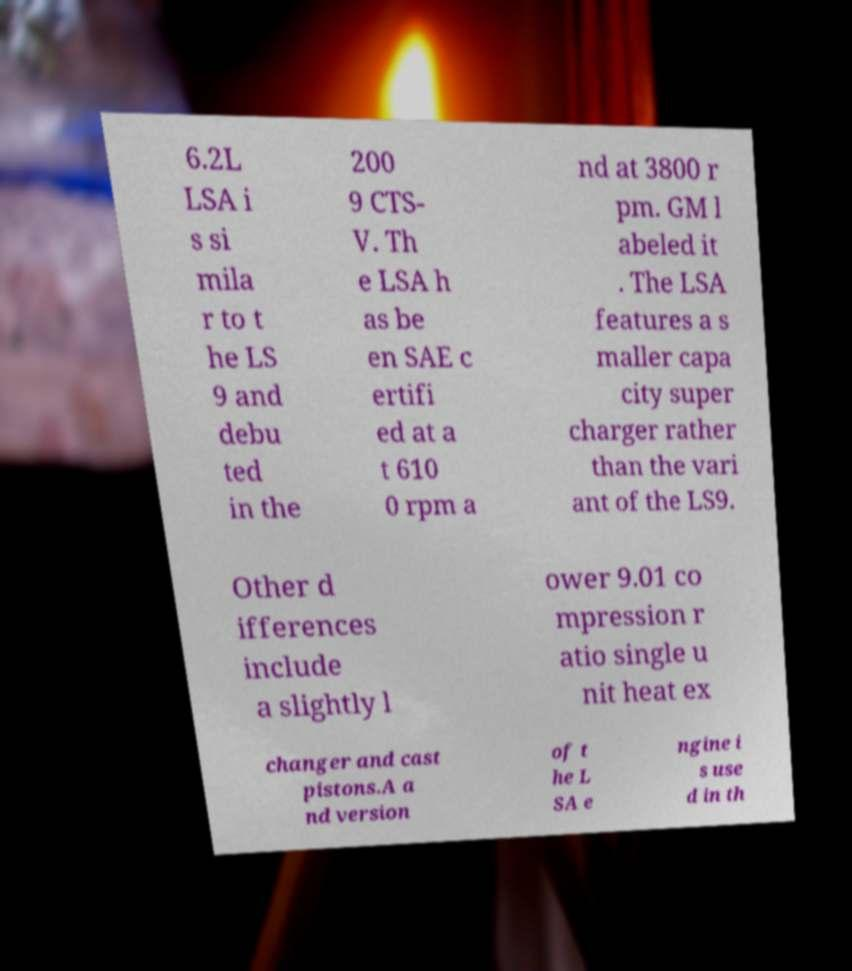Can you read and provide the text displayed in the image?This photo seems to have some interesting text. Can you extract and type it out for me? 6.2L LSA i s si mila r to t he LS 9 and debu ted in the 200 9 CTS- V. Th e LSA h as be en SAE c ertifi ed at a t 610 0 rpm a nd at 3800 r pm. GM l abeled it . The LSA features a s maller capa city super charger rather than the vari ant of the LS9. Other d ifferences include a slightly l ower 9.01 co mpression r atio single u nit heat ex changer and cast pistons.A a nd version of t he L SA e ngine i s use d in th 